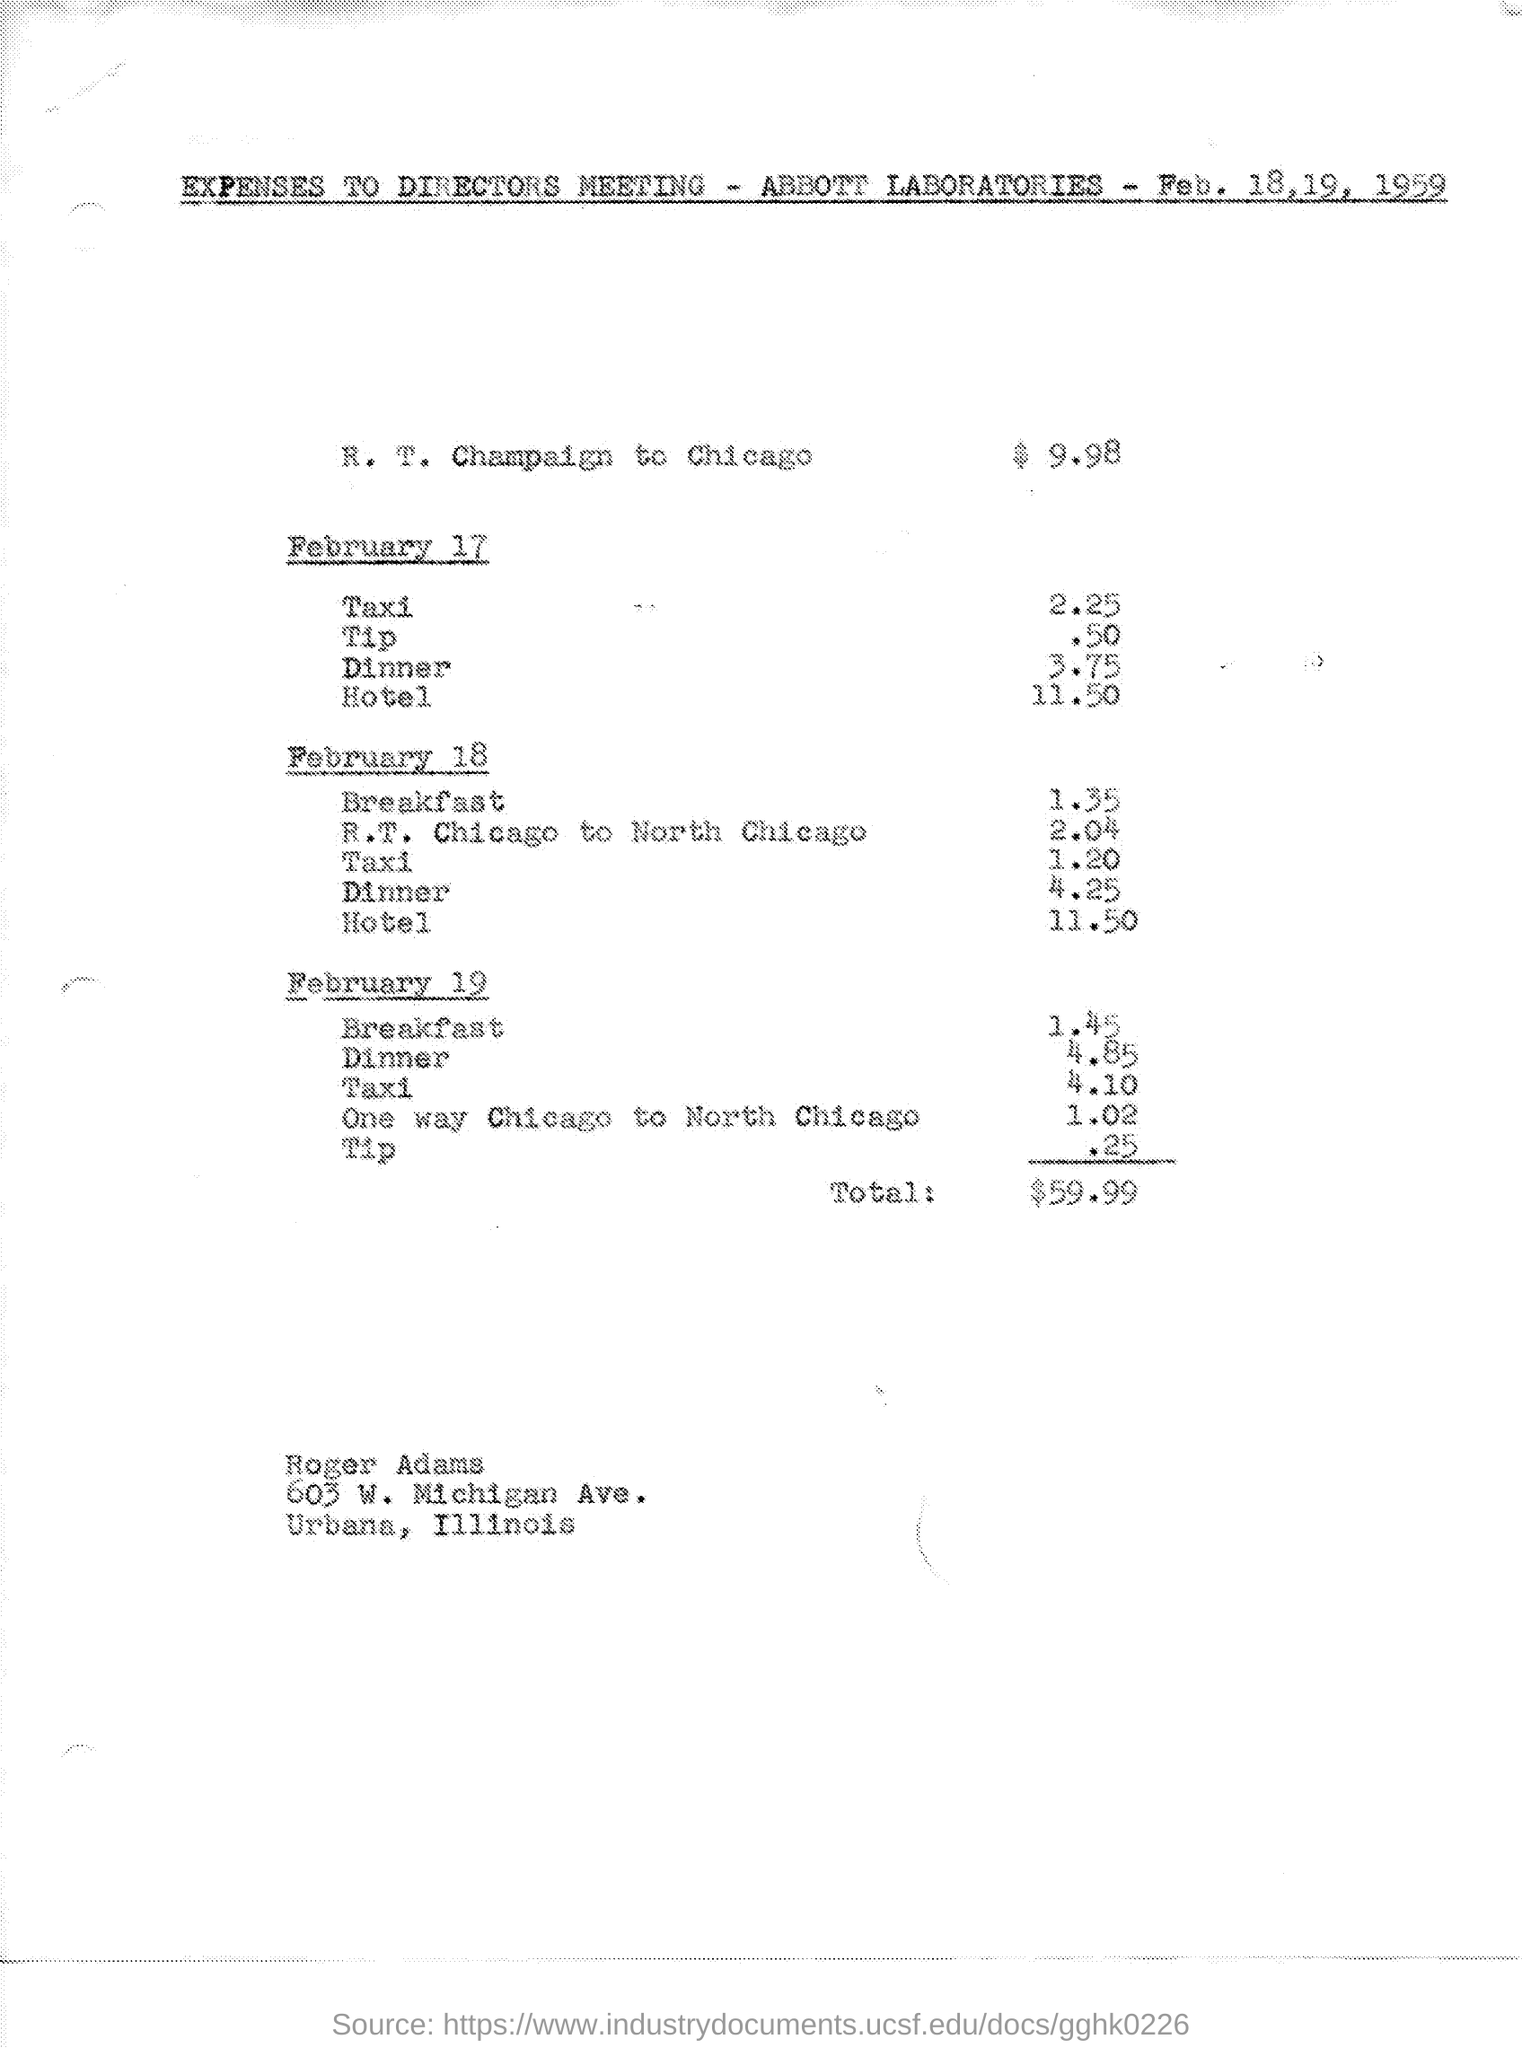Give some essential details in this illustration. Abbott laboratories is the laboratory mentioned. The total amount is $59.99. The amount of R. T. Champaign from Chicago is $9.98. Roger Adams' name is mentioned at the bottom of the page. 